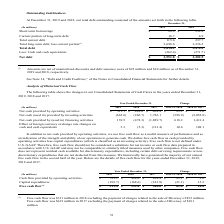According to Sealed Air Corporation's financial document, For Total long-term debt, less current portion in 2019, what is the net of unamortized discounts and debt issuance cost? According to the financial document, $25 million. The relevant text states: "f unamortized discounts and debt issuance costs of $25 million and $24 million as of December 31, 2019 and 2018, respectively...." Also, For what years of Outstanding Indebtedness are shown in the table?  The document shows two values: 2018 and 2019. From the document: "(In millions) 2019 2018 (In millions) 2019 2018..." Also, What unit is the table expressed by? According to the financial document, In millions. The relevant text states: "(In millions) 2019 2018..." Also, can you calculate: What is the percentage change of Net debt from 2018 to 2019? To answer this question, I need to perform calculations using the financial data. The calculation is: (3,551.8-3,202.5)/3,202.5, which equals 10.91 (percentage). This is based on the information: "h and cash equivalents (262.4) (271.7) Net debt $ 3,551.8 $ 3,202.5 equivalents (262.4) (271.7) Net debt $ 3,551.8 $ 3,202.5..." The key data points involved are: 3,202.5, 3,551.8. Also, can you calculate: What is the average annual Total debt for years 2018 and 2019? To answer this question, I need to perform calculations using the financial data. The calculation is: (3,814.2+3,474.2)/2, which equals 3644.2 (in millions). This is based on the information: "Total debt 3,814.2 3,474.2 Total debt 3,814.2 3,474.2..." The key data points involved are: 3,474.2, 3,814.2. Also, can you calculate: What is the Total long-term debt, less current portion for 2019, without accounting for unamortized discounts and debt issuance costs? Based on the calculation: 3,698.6-25, the result is 3673.6 (in millions). This is based on the information: "Total long-term debt, less current portion (1) 3,698.6 3,236.5 unamortized discounts and debt issuance costs of $25 million and $24 million as of December 31, 2019 and 2018, respectively...." The key data points involved are: 25, 3,698.6. 